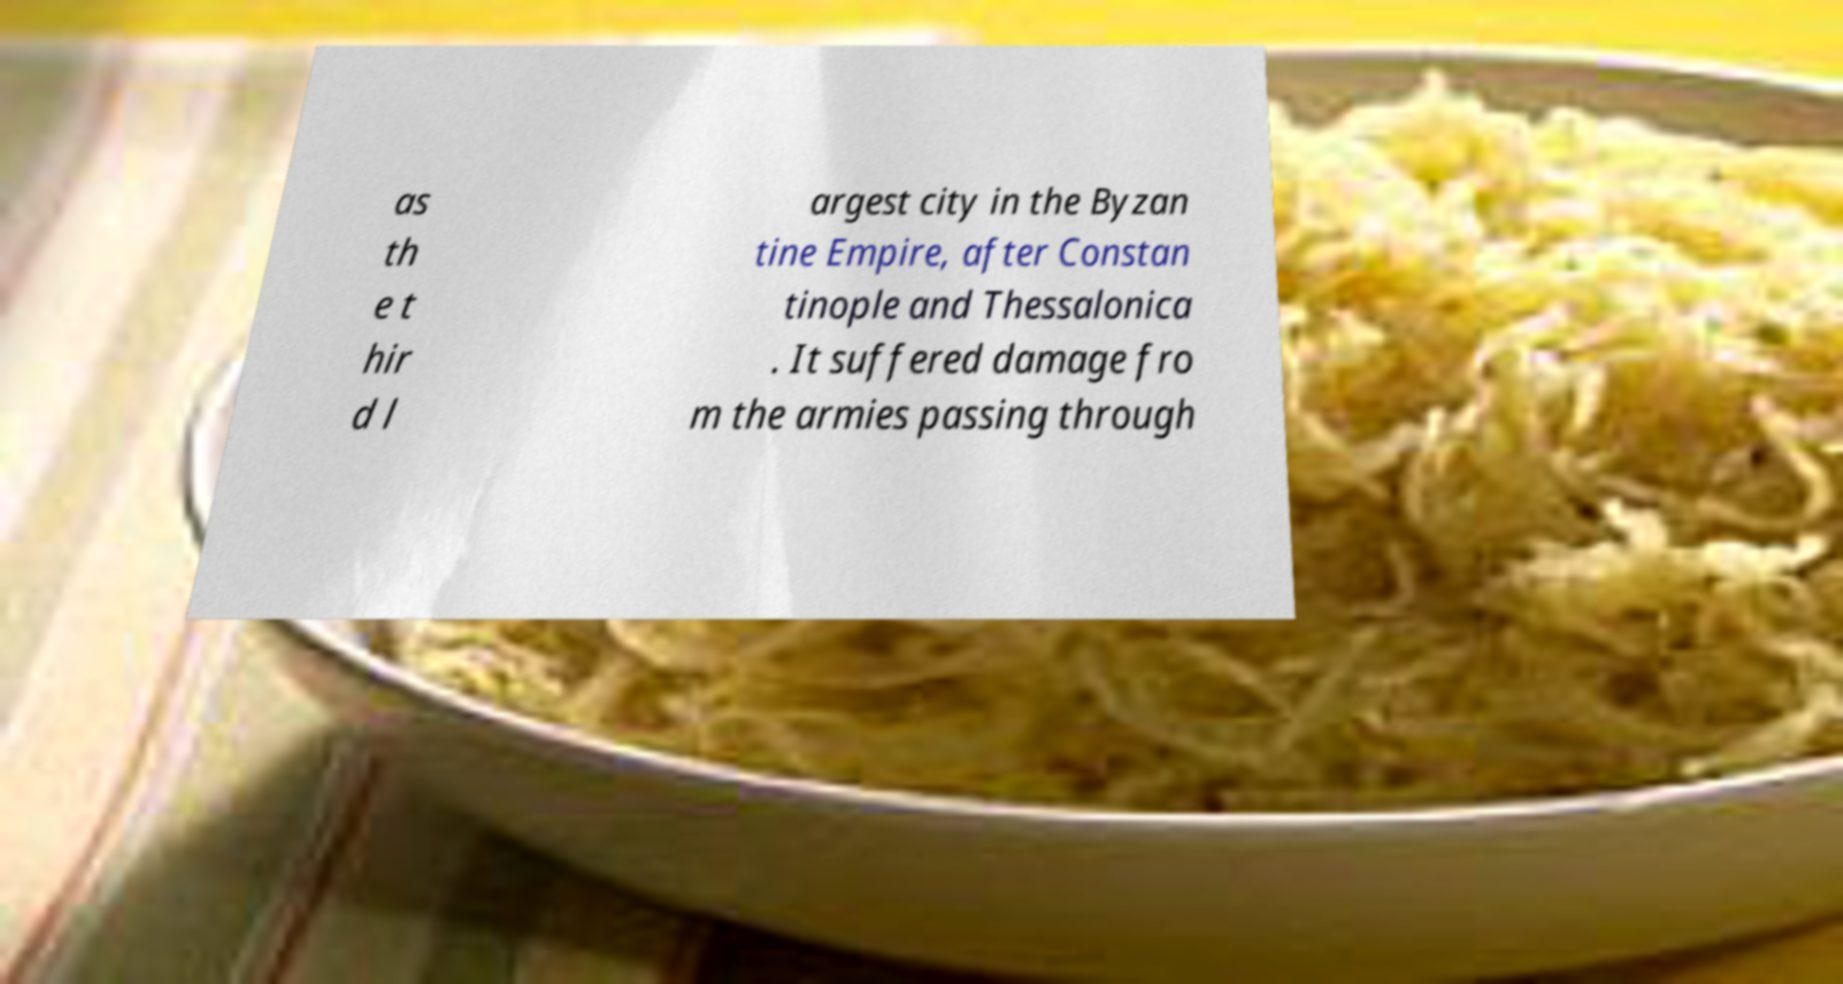Could you assist in decoding the text presented in this image and type it out clearly? as th e t hir d l argest city in the Byzan tine Empire, after Constan tinople and Thessalonica . It suffered damage fro m the armies passing through 